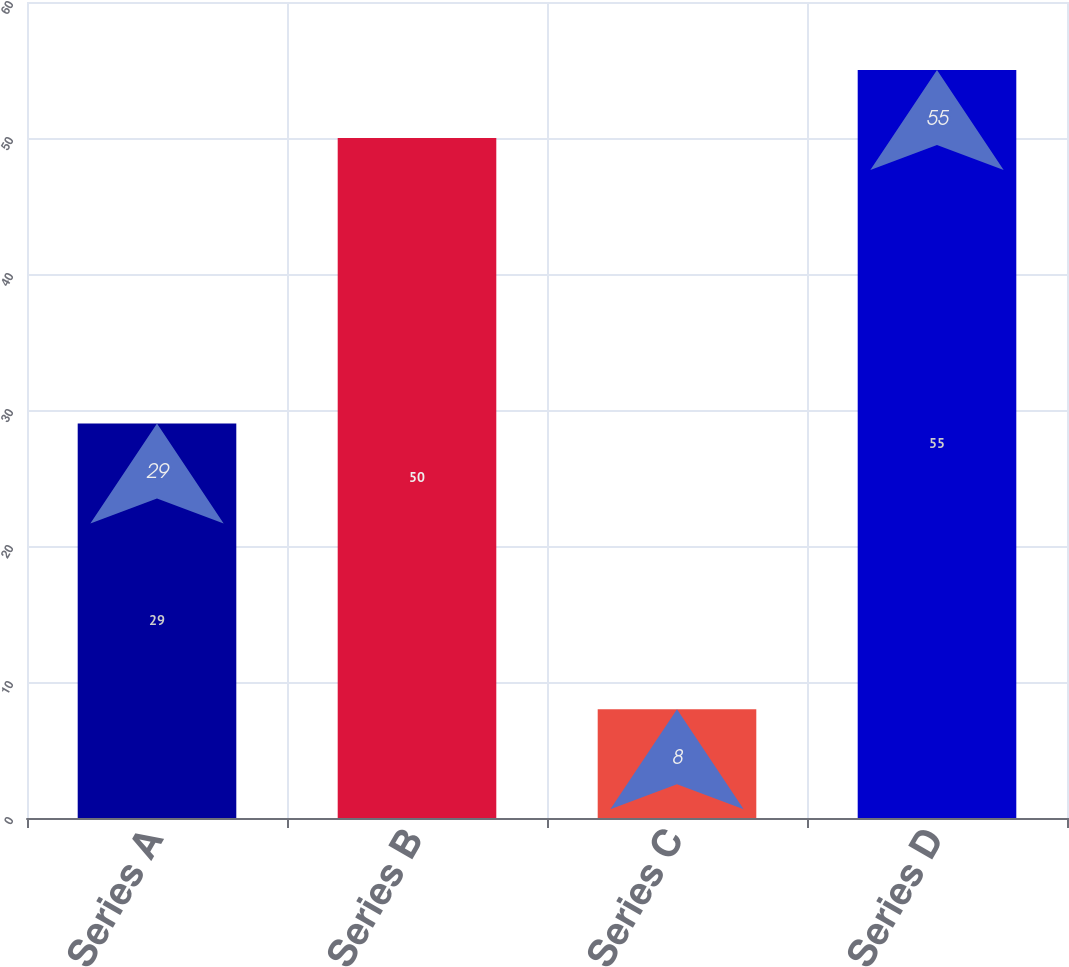Convert chart. <chart><loc_0><loc_0><loc_500><loc_500><bar_chart><fcel>Series A<fcel>Series B<fcel>Series C<fcel>Series D<nl><fcel>29<fcel>50<fcel>8<fcel>55<nl></chart> 